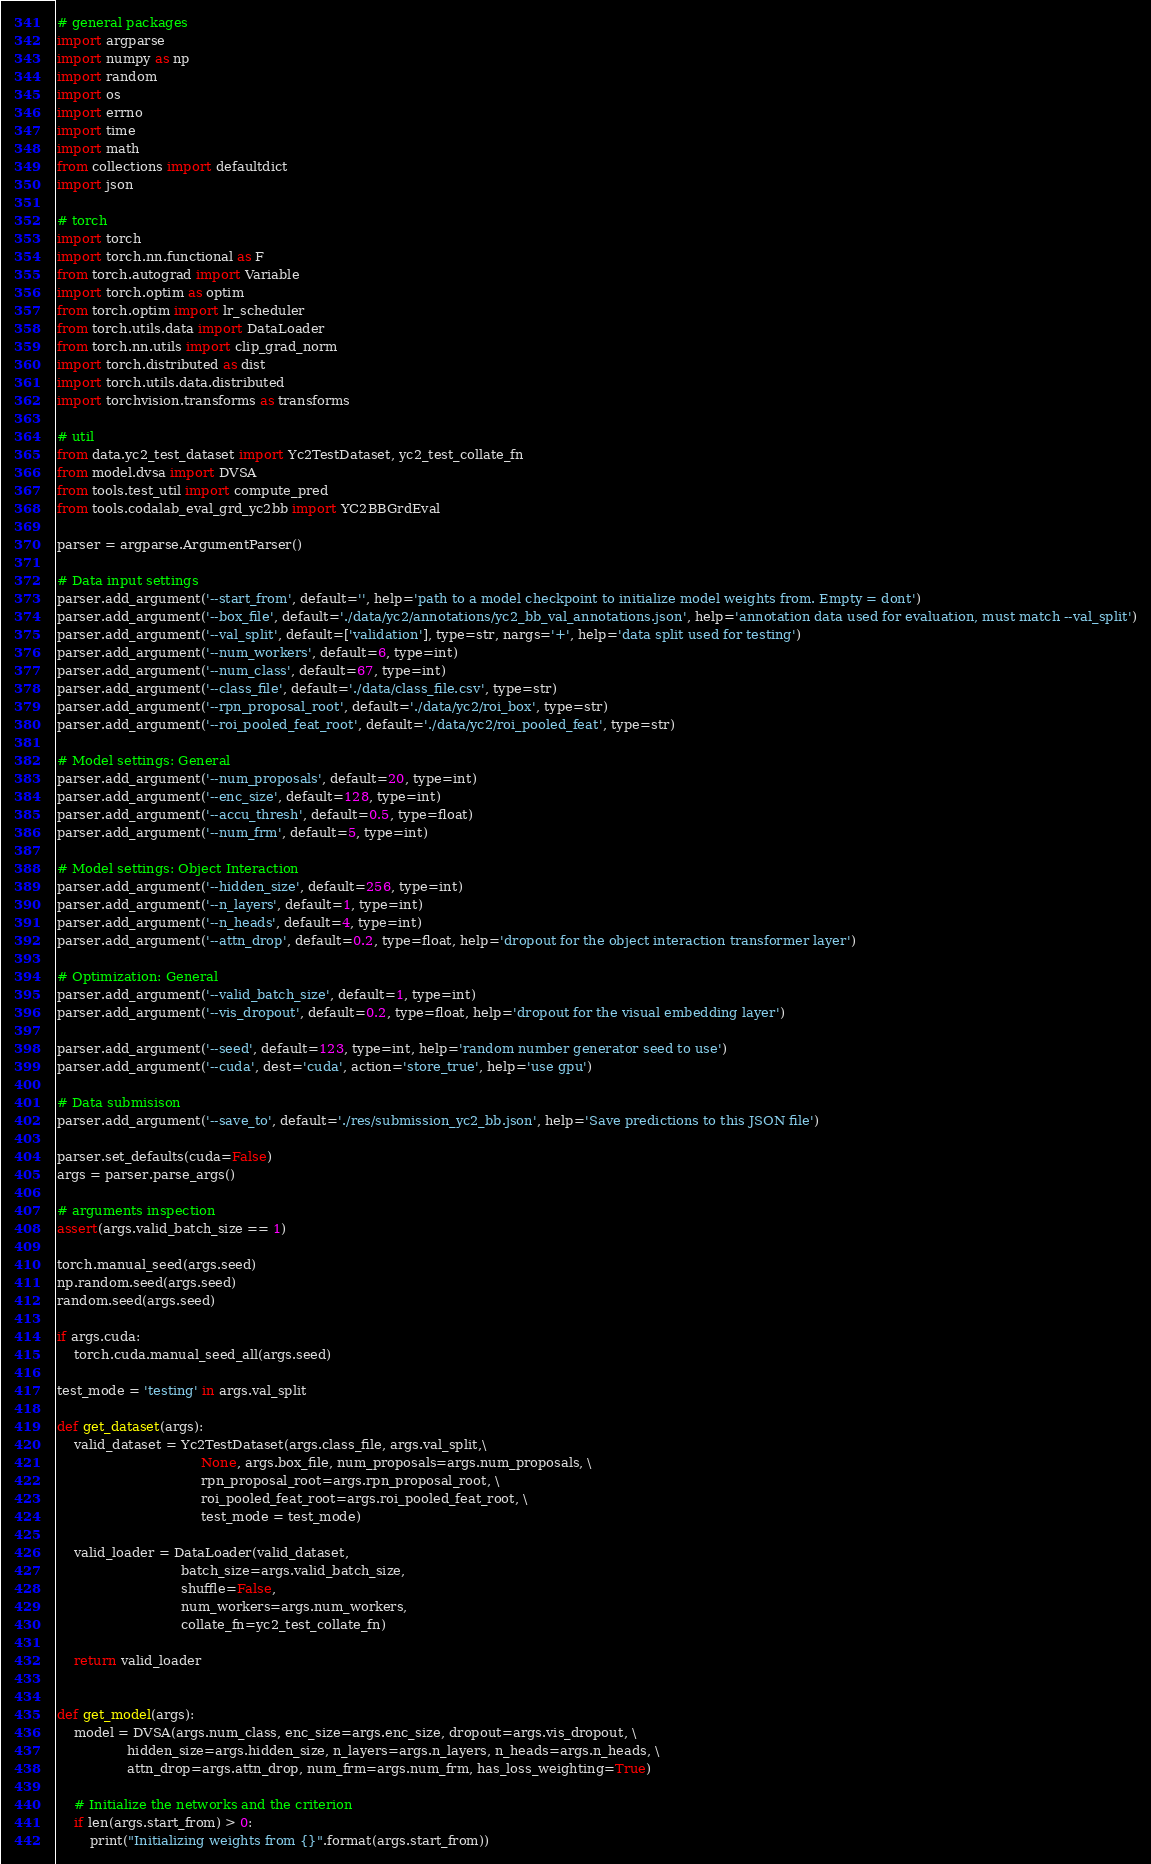Convert code to text. <code><loc_0><loc_0><loc_500><loc_500><_Python_>
# general packages
import argparse
import numpy as np
import random
import os
import errno
import time
import math
from collections import defaultdict
import json

# torch
import torch
import torch.nn.functional as F
from torch.autograd import Variable
import torch.optim as optim
from torch.optim import lr_scheduler
from torch.utils.data import DataLoader
from torch.nn.utils import clip_grad_norm
import torch.distributed as dist
import torch.utils.data.distributed
import torchvision.transforms as transforms

# util
from data.yc2_test_dataset import Yc2TestDataset, yc2_test_collate_fn
from model.dvsa import DVSA
from tools.test_util import compute_pred
from tools.codalab_eval_grd_yc2bb import YC2BBGrdEval

parser = argparse.ArgumentParser()

# Data input settings
parser.add_argument('--start_from', default='', help='path to a model checkpoint to initialize model weights from. Empty = dont')
parser.add_argument('--box_file', default='./data/yc2/annotations/yc2_bb_val_annotations.json', help='annotation data used for evaluation, must match --val_split')
parser.add_argument('--val_split', default=['validation'], type=str, nargs='+', help='data split used for testing')
parser.add_argument('--num_workers', default=6, type=int)
parser.add_argument('--num_class', default=67, type=int)
parser.add_argument('--class_file', default='./data/class_file.csv', type=str)
parser.add_argument('--rpn_proposal_root', default='./data/yc2/roi_box', type=str)
parser.add_argument('--roi_pooled_feat_root', default='./data/yc2/roi_pooled_feat', type=str)

# Model settings: General
parser.add_argument('--num_proposals', default=20, type=int)
parser.add_argument('--enc_size', default=128, type=int)
parser.add_argument('--accu_thresh', default=0.5, type=float)
parser.add_argument('--num_frm', default=5, type=int)

# Model settings: Object Interaction
parser.add_argument('--hidden_size', default=256, type=int)
parser.add_argument('--n_layers', default=1, type=int)
parser.add_argument('--n_heads', default=4, type=int)
parser.add_argument('--attn_drop', default=0.2, type=float, help='dropout for the object interaction transformer layer')

# Optimization: General
parser.add_argument('--valid_batch_size', default=1, type=int)
parser.add_argument('--vis_dropout', default=0.2, type=float, help='dropout for the visual embedding layer')

parser.add_argument('--seed', default=123, type=int, help='random number generator seed to use')
parser.add_argument('--cuda', dest='cuda', action='store_true', help='use gpu')

# Data submisison
parser.add_argument('--save_to', default='./res/submission_yc2_bb.json', help='Save predictions to this JSON file')

parser.set_defaults(cuda=False)
args = parser.parse_args()

# arguments inspection
assert(args.valid_batch_size == 1)

torch.manual_seed(args.seed)
np.random.seed(args.seed)
random.seed(args.seed)

if args.cuda:
    torch.cuda.manual_seed_all(args.seed)

test_mode = 'testing' in args.val_split

def get_dataset(args):
    valid_dataset = Yc2TestDataset(args.class_file, args.val_split,\
                                   None, args.box_file, num_proposals=args.num_proposals, \
                                   rpn_proposal_root=args.rpn_proposal_root, \
                                   roi_pooled_feat_root=args.roi_pooled_feat_root, \
                                   test_mode = test_mode)

    valid_loader = DataLoader(valid_dataset,
                              batch_size=args.valid_batch_size,
                              shuffle=False,
                              num_workers=args.num_workers,
                              collate_fn=yc2_test_collate_fn)

    return valid_loader


def get_model(args):
    model = DVSA(args.num_class, enc_size=args.enc_size, dropout=args.vis_dropout, \
                 hidden_size=args.hidden_size, n_layers=args.n_layers, n_heads=args.n_heads, \
                 attn_drop=args.attn_drop, num_frm=args.num_frm, has_loss_weighting=True)

    # Initialize the networks and the criterion
    if len(args.start_from) > 0:
        print("Initializing weights from {}".format(args.start_from))</code> 